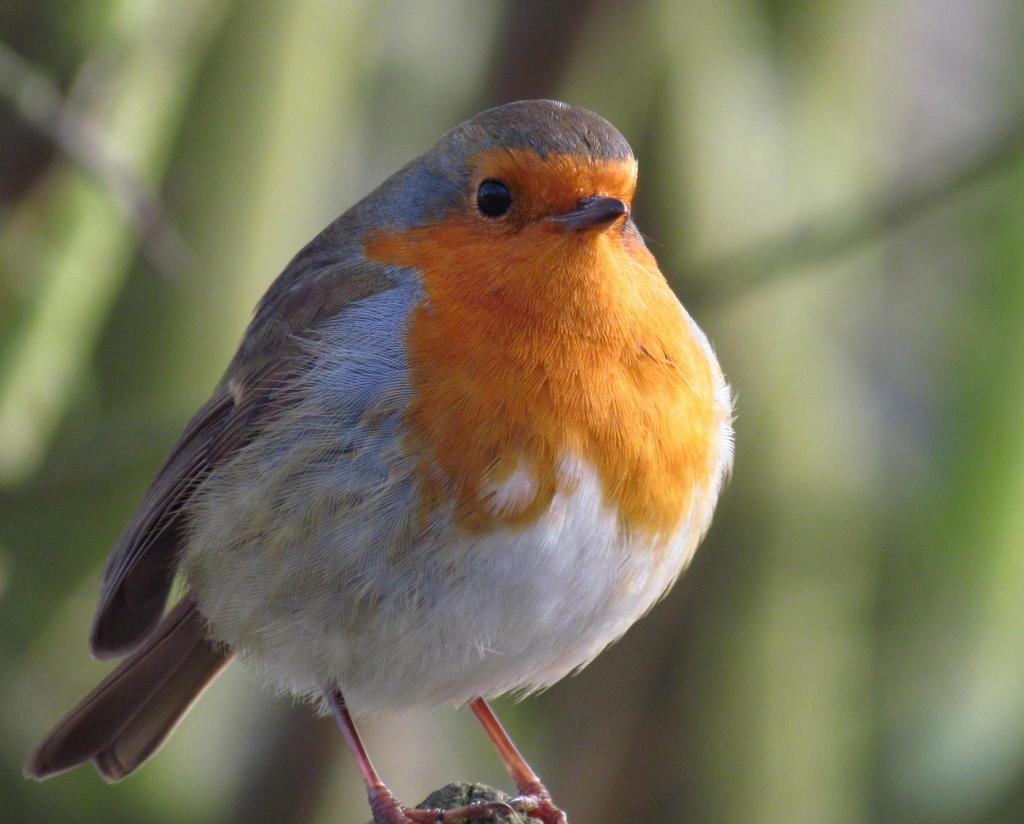What type of animal is in the image? There is a bird in the image. Where is the bird located in the image? The bird is in the front of the image. What can be observed about the background of the image? The background of the image is blurry. Can you tell me how many ducks are kissing the judge in the image? There are no ducks, judges, or kissing in the image; it features a bird in the front of a blurry background. 